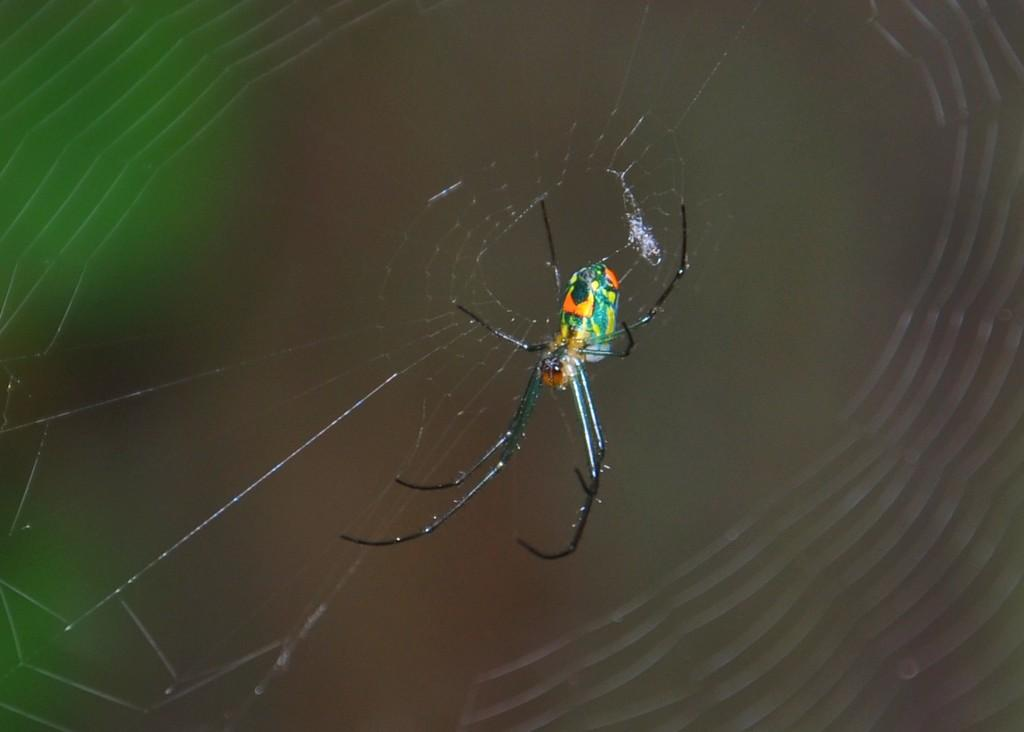What is the main subject of the image? There is a spider in the image. Can you describe the background of the image? The background of the image is blurry. What is the value of the crow in the image? There is no crow present in the image, so it is not possible to determine its value. 